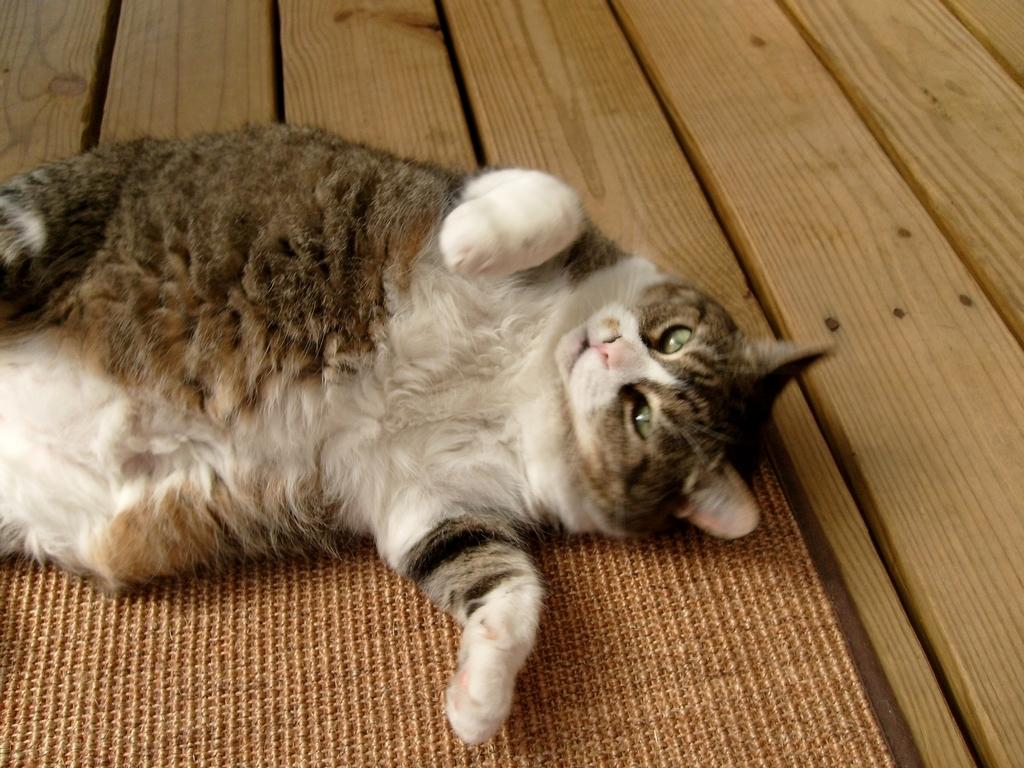What type of animal is present in the image? There is a cat in the image. What material is the wooden object made of? The wooden object is made of wood. What type of blood vessels can be seen in the image? There are no blood vessels present in the image. What type of curtain is hanging in the background of the image? There is no curtain present in the image. 